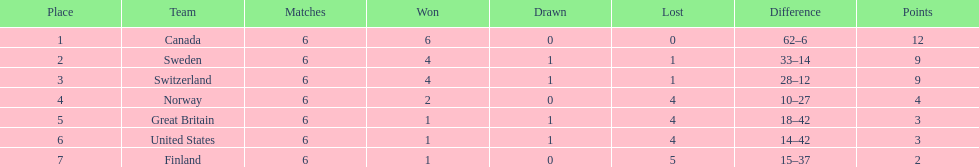Can you give me this table in json format? {'header': ['Place', 'Team', 'Matches', 'Won', 'Drawn', 'Lost', 'Difference', 'Points'], 'rows': [['1', 'Canada', '6', '6', '0', '0', '62–6', '12'], ['2', 'Sweden', '6', '4', '1', '1', '33–14', '9'], ['3', 'Switzerland', '6', '4', '1', '1', '28–12', '9'], ['4', 'Norway', '6', '2', '0', '4', '10–27', '4'], ['5', 'Great Britain', '6', '1', '1', '4', '18–42', '3'], ['6', 'United States', '6', '1', '1', '4', '14–42', '3'], ['7', 'Finland', '6', '1', '0', '5', '15–37', '2']]} Can you provide the names of the countries? Canada, Sweden, Switzerland, Norway, Great Britain, United States, Finland. How many times has switzerland won? 4. What is the number of wins for great britain? 1. Who had more wins between great britain and switzerland? Switzerland. 